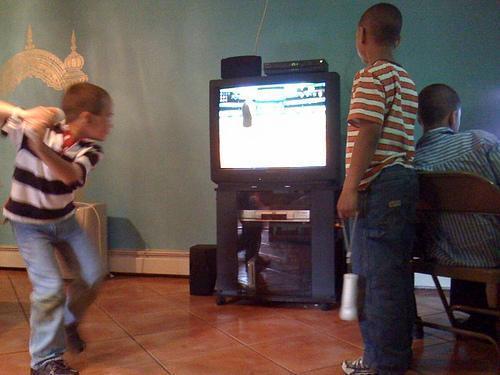How many boys are shown?
Give a very brief answer. 3. How many people are there?
Give a very brief answer. 3. 